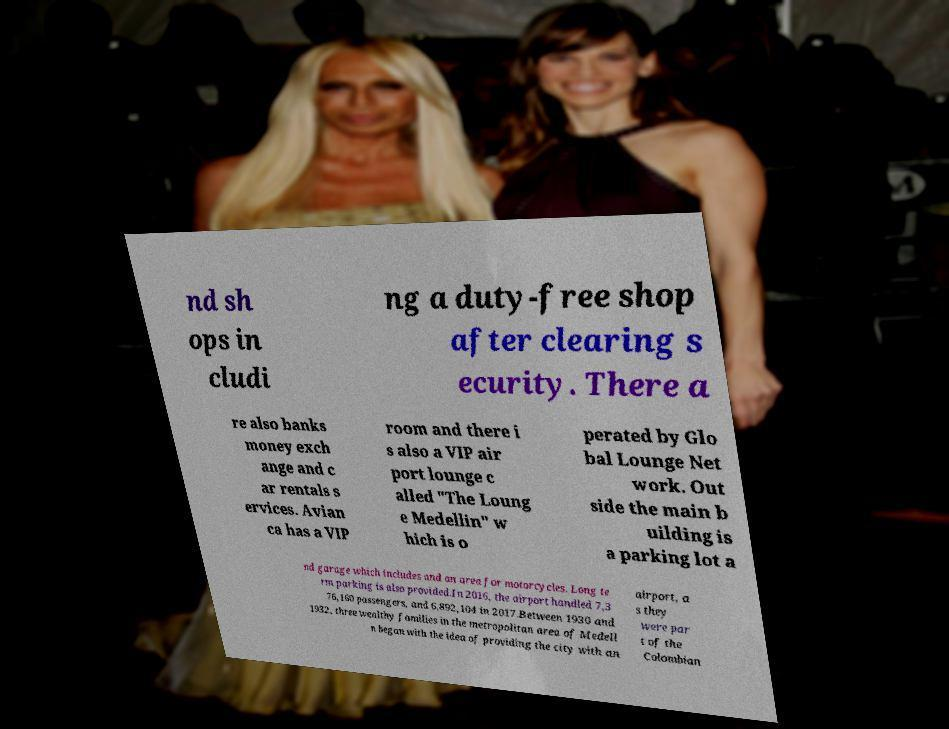Could you extract and type out the text from this image? nd sh ops in cludi ng a duty-free shop after clearing s ecurity. There a re also banks money exch ange and c ar rentals s ervices. Avian ca has a VIP room and there i s also a VIP air port lounge c alled "The Loung e Medellin" w hich is o perated by Glo bal Lounge Net work. Out side the main b uilding is a parking lot a nd garage which includes and an area for motorcycles. Long te rm parking is also provided.In 2016, the airport handled 7,3 76,160 passengers, and 6,892,104 in 2017.Between 1930 and 1932, three wealthy families in the metropolitan area of Medell n began with the idea of providing the city with an airport, a s they were par t of the Colombian 